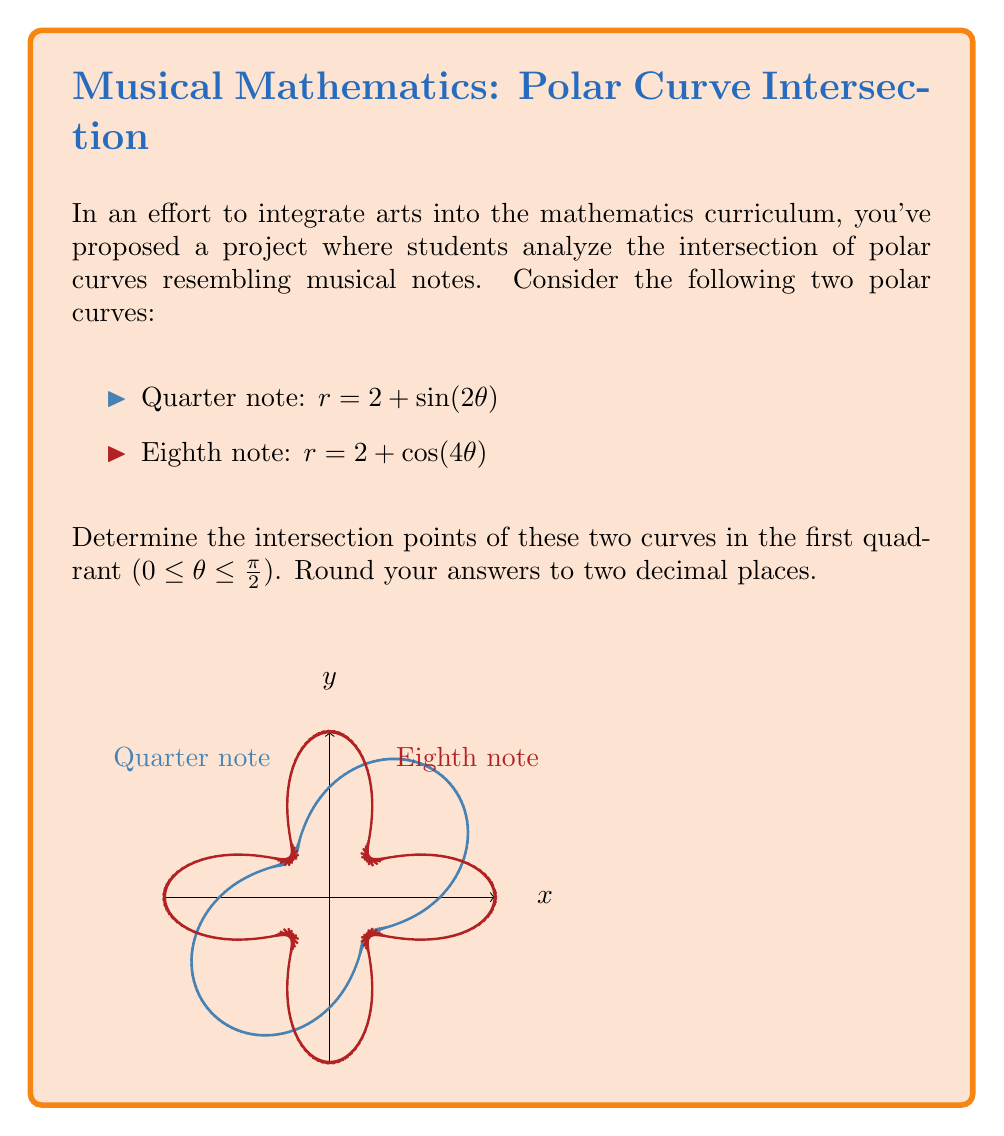Solve this math problem. To find the intersection points, we need to solve the equation:

$$ 2 + \sin(2\theta) = 2 + \cos(4\theta) $$

Simplifying:

$$ \sin(2\theta) = \cos(4\theta) $$

Using the trigonometric identity $\cos(4\theta) = 1 - 2\sin^2(2\theta)$, we get:

$$ \sin(2\theta) = 1 - 2\sin^2(2\theta) $$

Let $u = \sin(2\theta)$. Then we have:

$$ u = 1 - 2u^2 $$

Rearranging:

$$ 2u^2 + u - 1 = 0 $$

This is a quadratic equation. Using the quadratic formula:

$$ u = \frac{-1 \pm \sqrt{1^2 - 4(2)(-1)}}{2(2)} = \frac{-1 \pm \sqrt{9}}{4} $$

$$ u = \frac{-1 \pm 3}{4} $$

The positive solution is:

$$ u = \frac{1}{2} $$

Therefore:

$$ \sin(2\theta) = \frac{1}{2} $$

In the first quadrant, this gives us:

$$ 2\theta = \frac{\pi}{6} $$

$$ \theta = \frac{\pi}{12} \approx 0.26 \text{ radians} $$

To find r, we can use either equation:

$$ r = 2 + \sin(2(\frac{\pi}{12})) = 2 + \frac{1}{2} = 2.5 $$

Converting to Cartesian coordinates:

$$ x = r\cos(\theta) = 2.5\cos(\frac{\pi}{12}) \approx 2.42 $$
$$ y = r\sin(\theta) = 2.5\sin(\frac{\pi}{12}) \approx 0.64 $$
Answer: $(2.42, 0.64)$ 